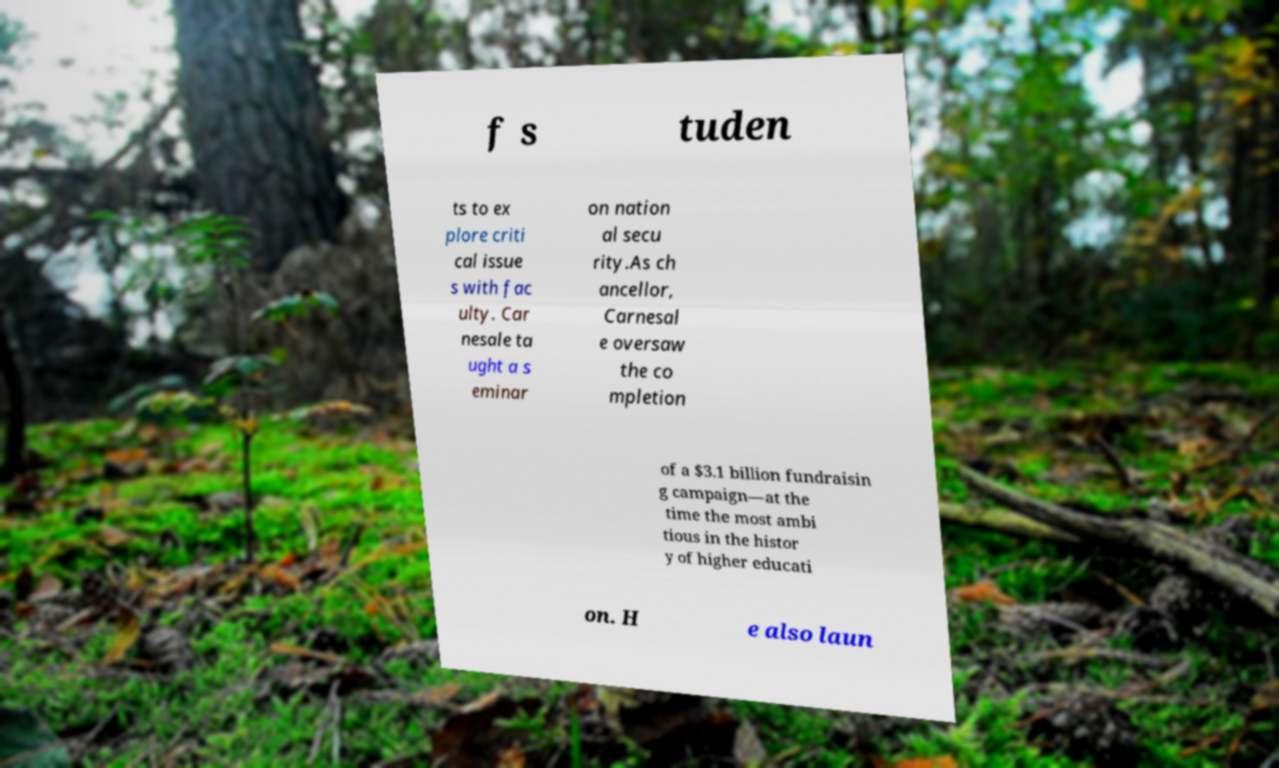What messages or text are displayed in this image? I need them in a readable, typed format. f s tuden ts to ex plore criti cal issue s with fac ulty. Car nesale ta ught a s eminar on nation al secu rity.As ch ancellor, Carnesal e oversaw the co mpletion of a $3.1 billion fundraisin g campaign—at the time the most ambi tious in the histor y of higher educati on. H e also laun 